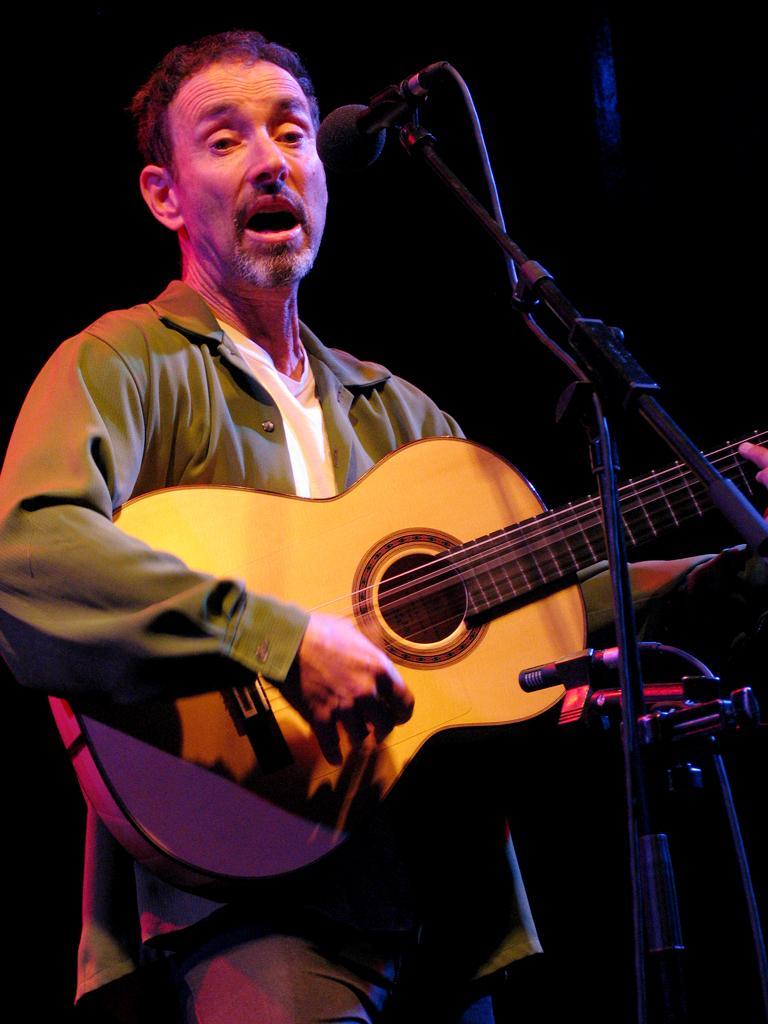Describe this image in one or two sentences. It is a concert, a man is playing a guitar he is singing a song , there is mike in front of him in the background it is dark. 